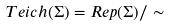<formula> <loc_0><loc_0><loc_500><loc_500>T e i c h ( \Sigma ) = R e p ( \Sigma ) / \sim</formula> 